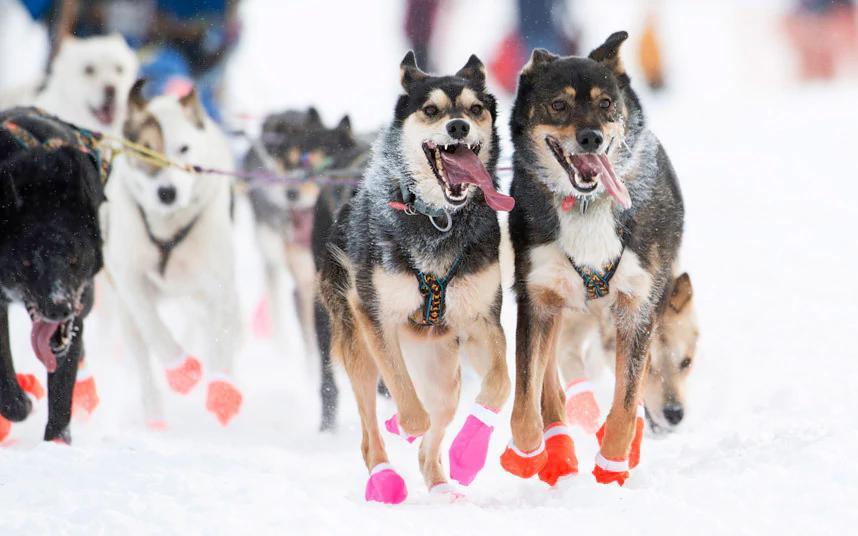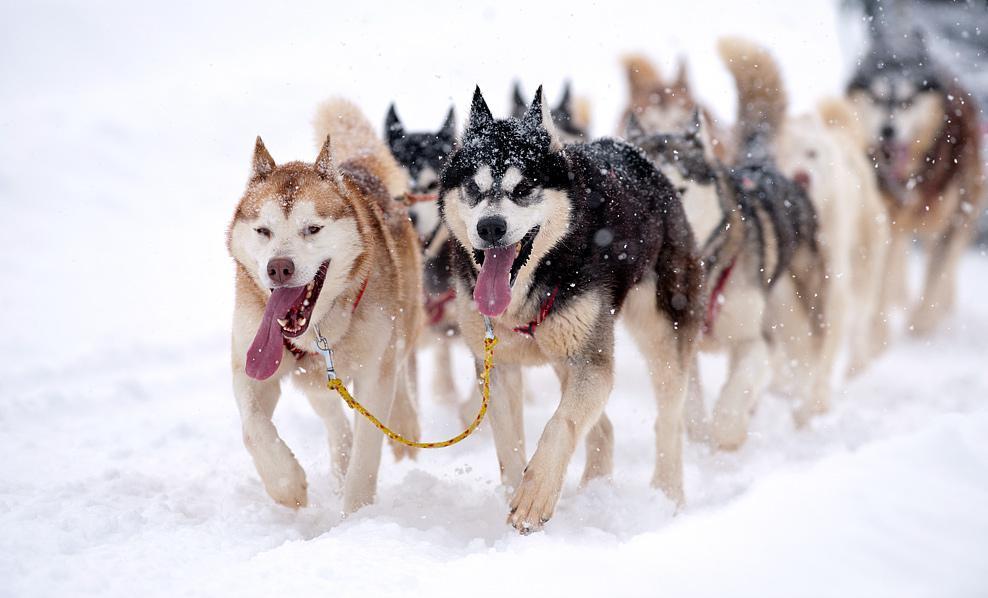The first image is the image on the left, the second image is the image on the right. For the images shown, is this caption "There are dogs wearing colorful paw coverups." true? Answer yes or no. Yes. The first image is the image on the left, the second image is the image on the right. For the images shown, is this caption "There are dogs wearing colored socks in at least one image." true? Answer yes or no. Yes. 